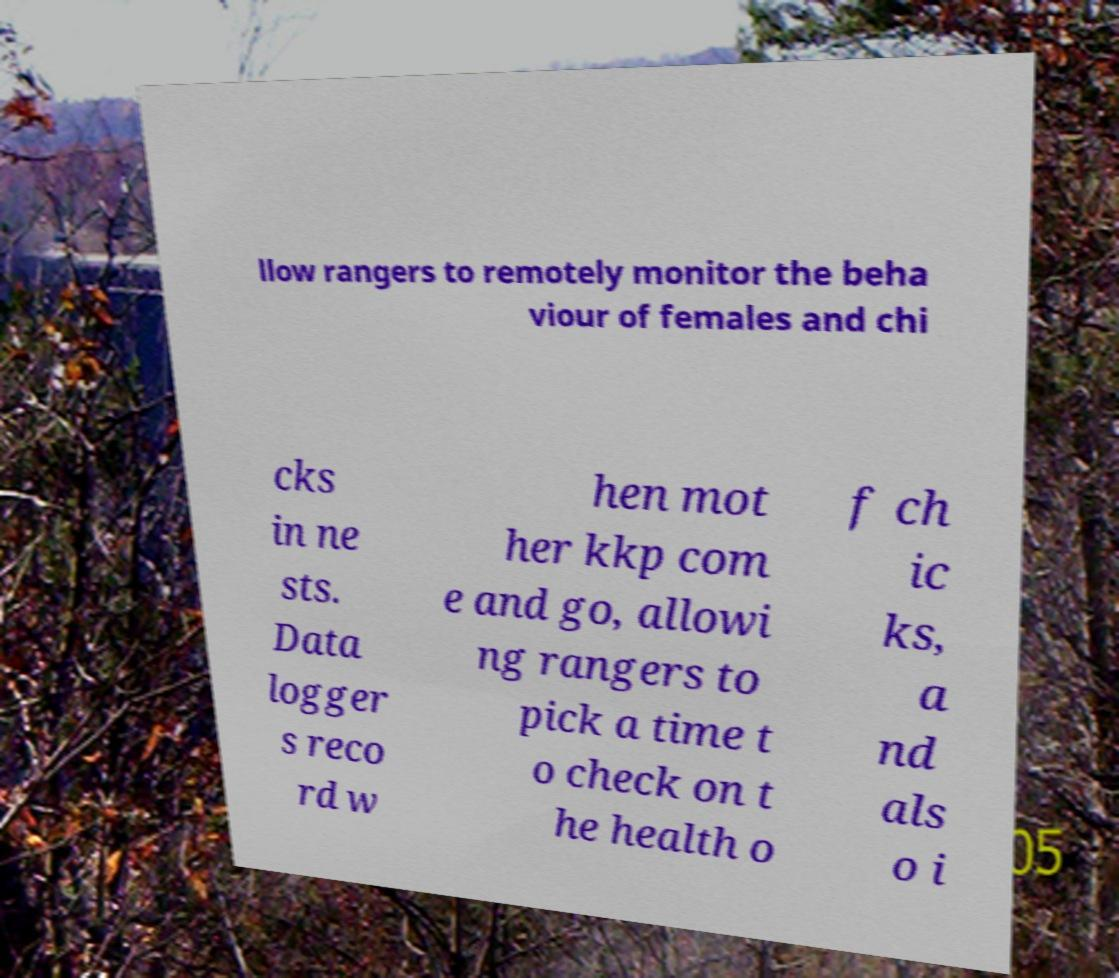Could you extract and type out the text from this image? llow rangers to remotely monitor the beha viour of females and chi cks in ne sts. Data logger s reco rd w hen mot her kkp com e and go, allowi ng rangers to pick a time t o check on t he health o f ch ic ks, a nd als o i 